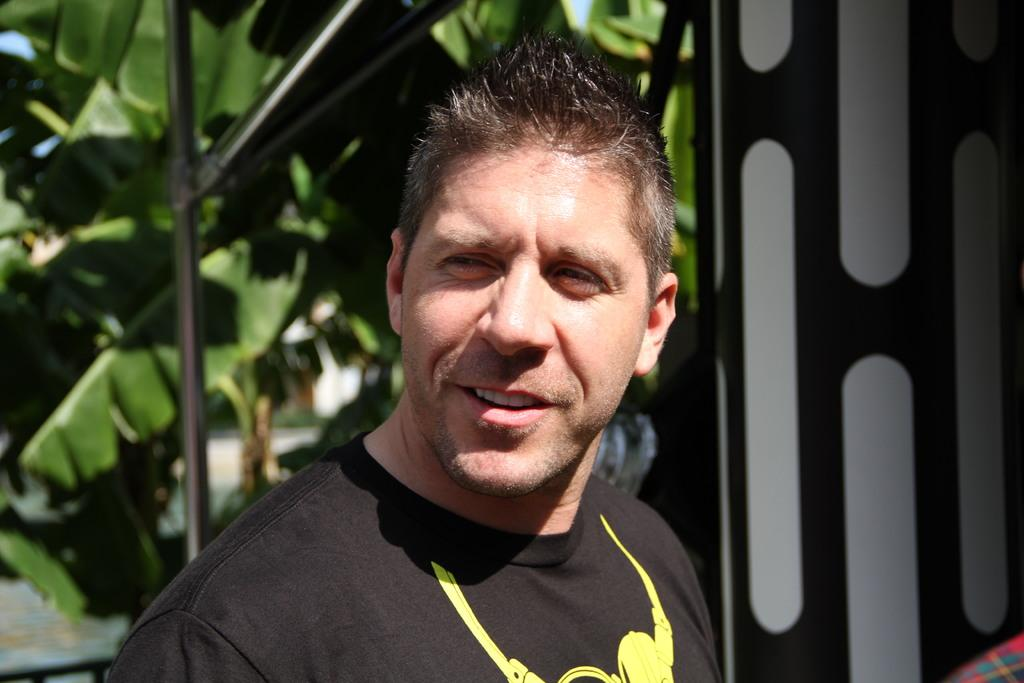What is the main subject of the image? There is a person in the image. What can be seen in the background of the image? There are leaves and other objects visible in the background of the image. How does the river in the image affect the person's clothing? There is no river present in the image, so it cannot affect the person's clothing. 